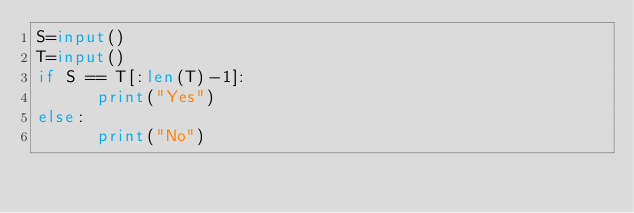Convert code to text. <code><loc_0><loc_0><loc_500><loc_500><_Python_>S=input()
T=input()
if S == T[:len(T)-1]:
      print("Yes")
else:
      print("No")</code> 